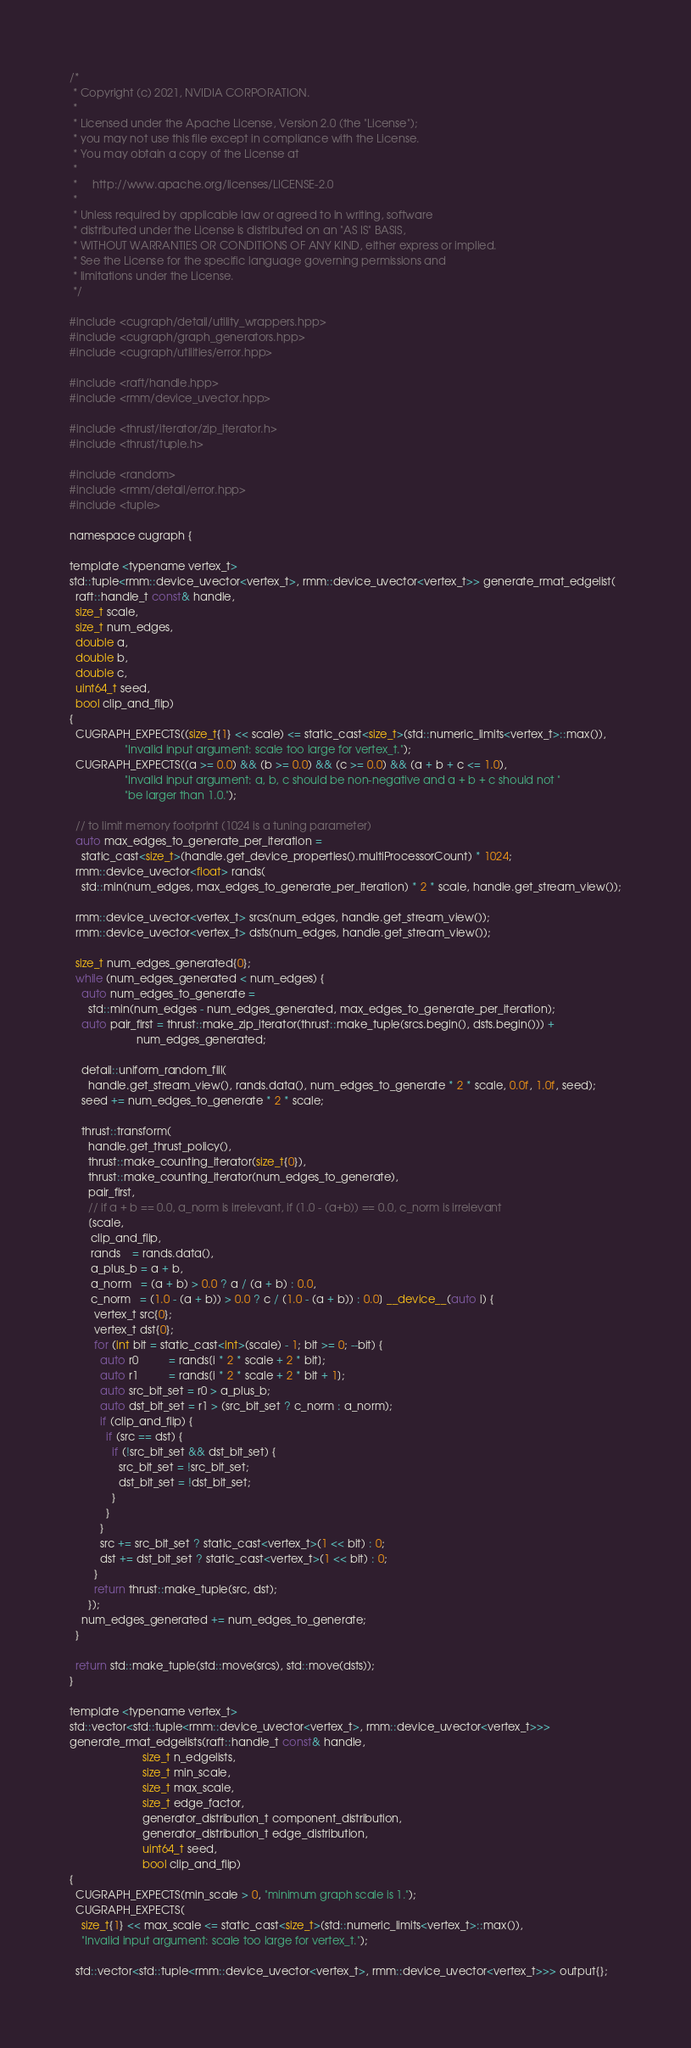Convert code to text. <code><loc_0><loc_0><loc_500><loc_500><_Cuda_>/*
 * Copyright (c) 2021, NVIDIA CORPORATION.
 *
 * Licensed under the Apache License, Version 2.0 (the "License");
 * you may not use this file except in compliance with the License.
 * You may obtain a copy of the License at
 *
 *     http://www.apache.org/licenses/LICENSE-2.0
 *
 * Unless required by applicable law or agreed to in writing, software
 * distributed under the License is distributed on an "AS IS" BASIS,
 * WITHOUT WARRANTIES OR CONDITIONS OF ANY KIND, either express or implied.
 * See the License for the specific language governing permissions and
 * limitations under the License.
 */

#include <cugraph/detail/utility_wrappers.hpp>
#include <cugraph/graph_generators.hpp>
#include <cugraph/utilities/error.hpp>

#include <raft/handle.hpp>
#include <rmm/device_uvector.hpp>

#include <thrust/iterator/zip_iterator.h>
#include <thrust/tuple.h>

#include <random>
#include <rmm/detail/error.hpp>
#include <tuple>

namespace cugraph {

template <typename vertex_t>
std::tuple<rmm::device_uvector<vertex_t>, rmm::device_uvector<vertex_t>> generate_rmat_edgelist(
  raft::handle_t const& handle,
  size_t scale,
  size_t num_edges,
  double a,
  double b,
  double c,
  uint64_t seed,
  bool clip_and_flip)
{
  CUGRAPH_EXPECTS((size_t{1} << scale) <= static_cast<size_t>(std::numeric_limits<vertex_t>::max()),
                  "Invalid input argument: scale too large for vertex_t.");
  CUGRAPH_EXPECTS((a >= 0.0) && (b >= 0.0) && (c >= 0.0) && (a + b + c <= 1.0),
                  "Invalid input argument: a, b, c should be non-negative and a + b + c should not "
                  "be larger than 1.0.");

  // to limit memory footprint (1024 is a tuning parameter)
  auto max_edges_to_generate_per_iteration =
    static_cast<size_t>(handle.get_device_properties().multiProcessorCount) * 1024;
  rmm::device_uvector<float> rands(
    std::min(num_edges, max_edges_to_generate_per_iteration) * 2 * scale, handle.get_stream_view());

  rmm::device_uvector<vertex_t> srcs(num_edges, handle.get_stream_view());
  rmm::device_uvector<vertex_t> dsts(num_edges, handle.get_stream_view());

  size_t num_edges_generated{0};
  while (num_edges_generated < num_edges) {
    auto num_edges_to_generate =
      std::min(num_edges - num_edges_generated, max_edges_to_generate_per_iteration);
    auto pair_first = thrust::make_zip_iterator(thrust::make_tuple(srcs.begin(), dsts.begin())) +
                      num_edges_generated;

    detail::uniform_random_fill(
      handle.get_stream_view(), rands.data(), num_edges_to_generate * 2 * scale, 0.0f, 1.0f, seed);
    seed += num_edges_to_generate * 2 * scale;

    thrust::transform(
      handle.get_thrust_policy(),
      thrust::make_counting_iterator(size_t{0}),
      thrust::make_counting_iterator(num_edges_to_generate),
      pair_first,
      // if a + b == 0.0, a_norm is irrelevant, if (1.0 - (a+b)) == 0.0, c_norm is irrelevant
      [scale,
       clip_and_flip,
       rands    = rands.data(),
       a_plus_b = a + b,
       a_norm   = (a + b) > 0.0 ? a / (a + b) : 0.0,
       c_norm   = (1.0 - (a + b)) > 0.0 ? c / (1.0 - (a + b)) : 0.0] __device__(auto i) {
        vertex_t src{0};
        vertex_t dst{0};
        for (int bit = static_cast<int>(scale) - 1; bit >= 0; --bit) {
          auto r0          = rands[i * 2 * scale + 2 * bit];
          auto r1          = rands[i * 2 * scale + 2 * bit + 1];
          auto src_bit_set = r0 > a_plus_b;
          auto dst_bit_set = r1 > (src_bit_set ? c_norm : a_norm);
          if (clip_and_flip) {
            if (src == dst) {
              if (!src_bit_set && dst_bit_set) {
                src_bit_set = !src_bit_set;
                dst_bit_set = !dst_bit_set;
              }
            }
          }
          src += src_bit_set ? static_cast<vertex_t>(1 << bit) : 0;
          dst += dst_bit_set ? static_cast<vertex_t>(1 << bit) : 0;
        }
        return thrust::make_tuple(src, dst);
      });
    num_edges_generated += num_edges_to_generate;
  }

  return std::make_tuple(std::move(srcs), std::move(dsts));
}

template <typename vertex_t>
std::vector<std::tuple<rmm::device_uvector<vertex_t>, rmm::device_uvector<vertex_t>>>
generate_rmat_edgelists(raft::handle_t const& handle,
                        size_t n_edgelists,
                        size_t min_scale,
                        size_t max_scale,
                        size_t edge_factor,
                        generator_distribution_t component_distribution,
                        generator_distribution_t edge_distribution,
                        uint64_t seed,
                        bool clip_and_flip)
{
  CUGRAPH_EXPECTS(min_scale > 0, "minimum graph scale is 1.");
  CUGRAPH_EXPECTS(
    size_t{1} << max_scale <= static_cast<size_t>(std::numeric_limits<vertex_t>::max()),
    "Invalid input argument: scale too large for vertex_t.");

  std::vector<std::tuple<rmm::device_uvector<vertex_t>, rmm::device_uvector<vertex_t>>> output{};</code> 